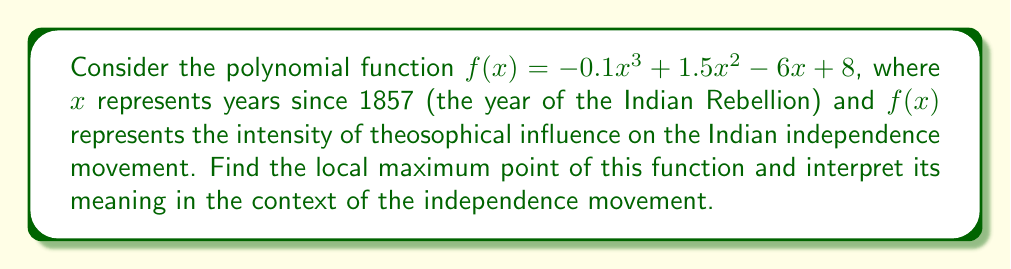Could you help me with this problem? To find the local maximum point of the polynomial function, we need to follow these steps:

1) First, find the derivative of the function:
   $f'(x) = -0.3x^2 + 3x - 6$

2) Set the derivative equal to zero and solve for x:
   $-0.3x^2 + 3x - 6 = 0$

3) This is a quadratic equation. We can solve it using the quadratic formula:
   $x = \frac{-b \pm \sqrt{b^2 - 4ac}}{2a}$

   Where $a = -0.3$, $b = 3$, and $c = -6$

4) Plugging in these values:
   $x = \frac{-3 \pm \sqrt{3^2 - 4(-0.3)(-6)}}{2(-0.3)}$
   $= \frac{-3 \pm \sqrt{9 - 7.2}}{-0.6}$
   $= \frac{-3 \pm \sqrt{1.8}}{-0.6}$
   $= \frac{-3 \pm 1.34}{-0.6}$

5) This gives us two solutions:
   $x_1 = \frac{-3 + 1.34}{-0.6} \approx 2.77$
   $x_2 = \frac{-3 - 1.34}{-0.6} \approx 7.23$

6) To determine which of these is the maximum point, we can check the second derivative:
   $f''(x) = -0.6x + 3$

   At $x = 2.77$, $f''(2.77) < 0$, indicating a local maximum.
   At $x = 7.23$, $f''(7.23) > 0$, indicating a local minimum.

7) Therefore, the local maximum occurs at $x \approx 2.77$.

8) To find the y-coordinate of this point, we plug this x-value back into the original function:
   $f(2.77) \approx -0.1(2.77)^3 + 1.5(2.77)^2 - 6(2.77) + 8 \approx 9.95$

9) Interpreting this result:
   The local maximum occurs approximately 2.77 years after 1857, which is around early 1860. This suggests that the theosophical influence on the Indian independence movement reached its peak intensity around this time, possibly coinciding with the formation of early nationalist groups or significant political events of that period.
Answer: The local maximum point is approximately (2.77, 9.95), occurring around early 1860 and representing the peak of theosophical influence on the Indian independence movement during this period. 